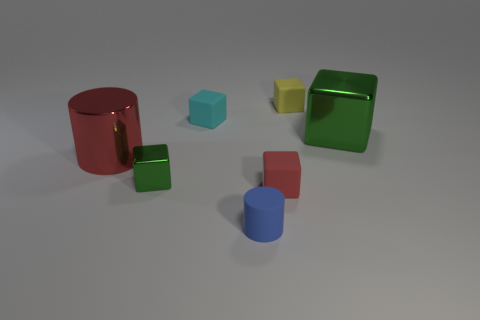What is the shape of the large thing that is the same color as the small metallic object?
Keep it short and to the point. Cube. How many other objects are there of the same shape as the yellow object?
Offer a terse response. 4. How many objects are either small things that are behind the small green object or green blocks on the right side of the cyan matte thing?
Offer a very short reply. 3. What is the size of the rubber block that is both behind the red rubber block and to the right of the small blue matte cylinder?
Offer a very short reply. Small. Is the shape of the green object that is to the right of the blue cylinder the same as  the tiny blue thing?
Make the answer very short. No. How big is the green shiny thing to the left of the green object right of the tiny green metallic object that is to the left of the cyan block?
Your answer should be compact. Small. What is the size of the rubber block that is the same color as the large cylinder?
Your answer should be very brief. Small. How many things are large red shiny cylinders or small red rubber blocks?
Ensure brevity in your answer.  2. There is a small matte thing that is to the left of the small red rubber cube and in front of the small cyan cube; what shape is it?
Offer a terse response. Cylinder. Do the tiny blue thing and the green thing on the right side of the tiny metallic block have the same shape?
Keep it short and to the point. No. 